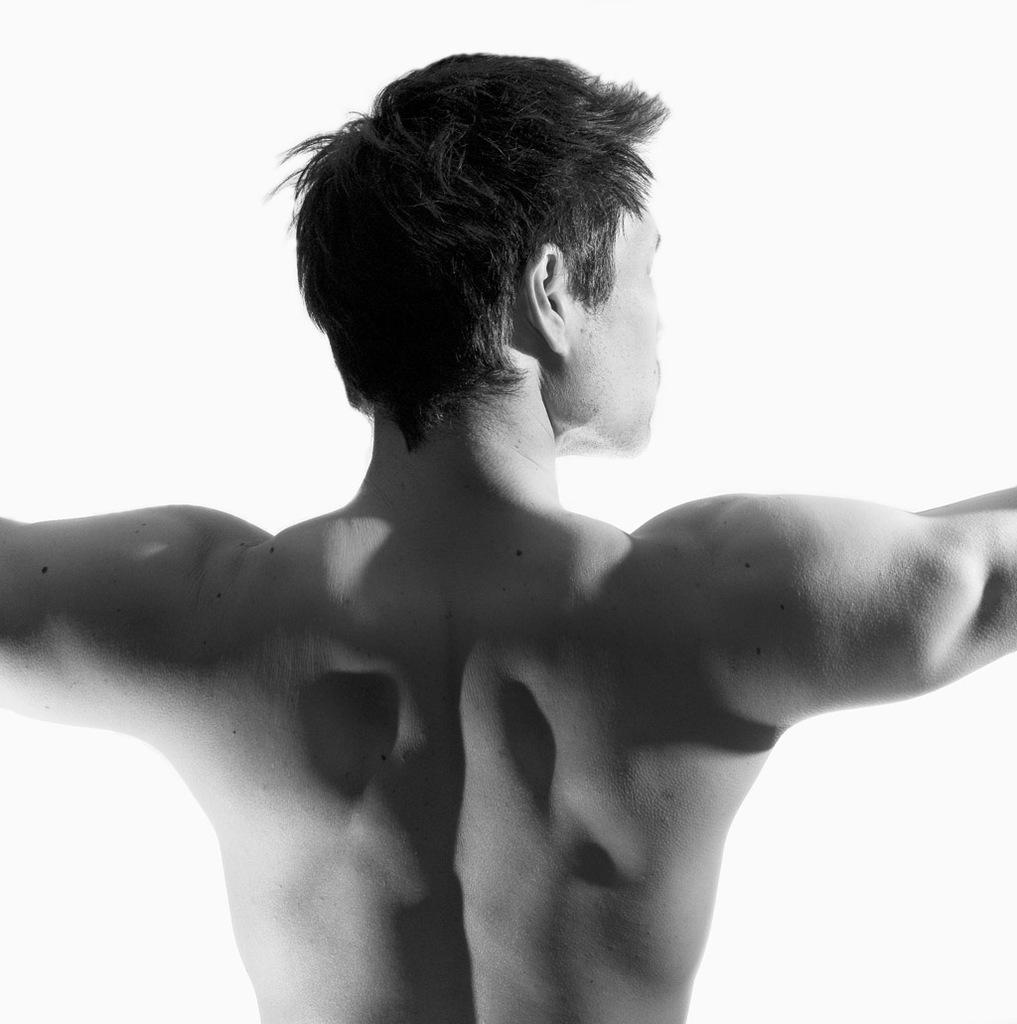What is the main subject of the image? There is a person in the center of the image. What color is the background of the image? The background of the image is black. Can you see the person swimming at the seashore in the image? There is no seashore or swimming activity depicted in the image; it only features a person in the center with a black background. 